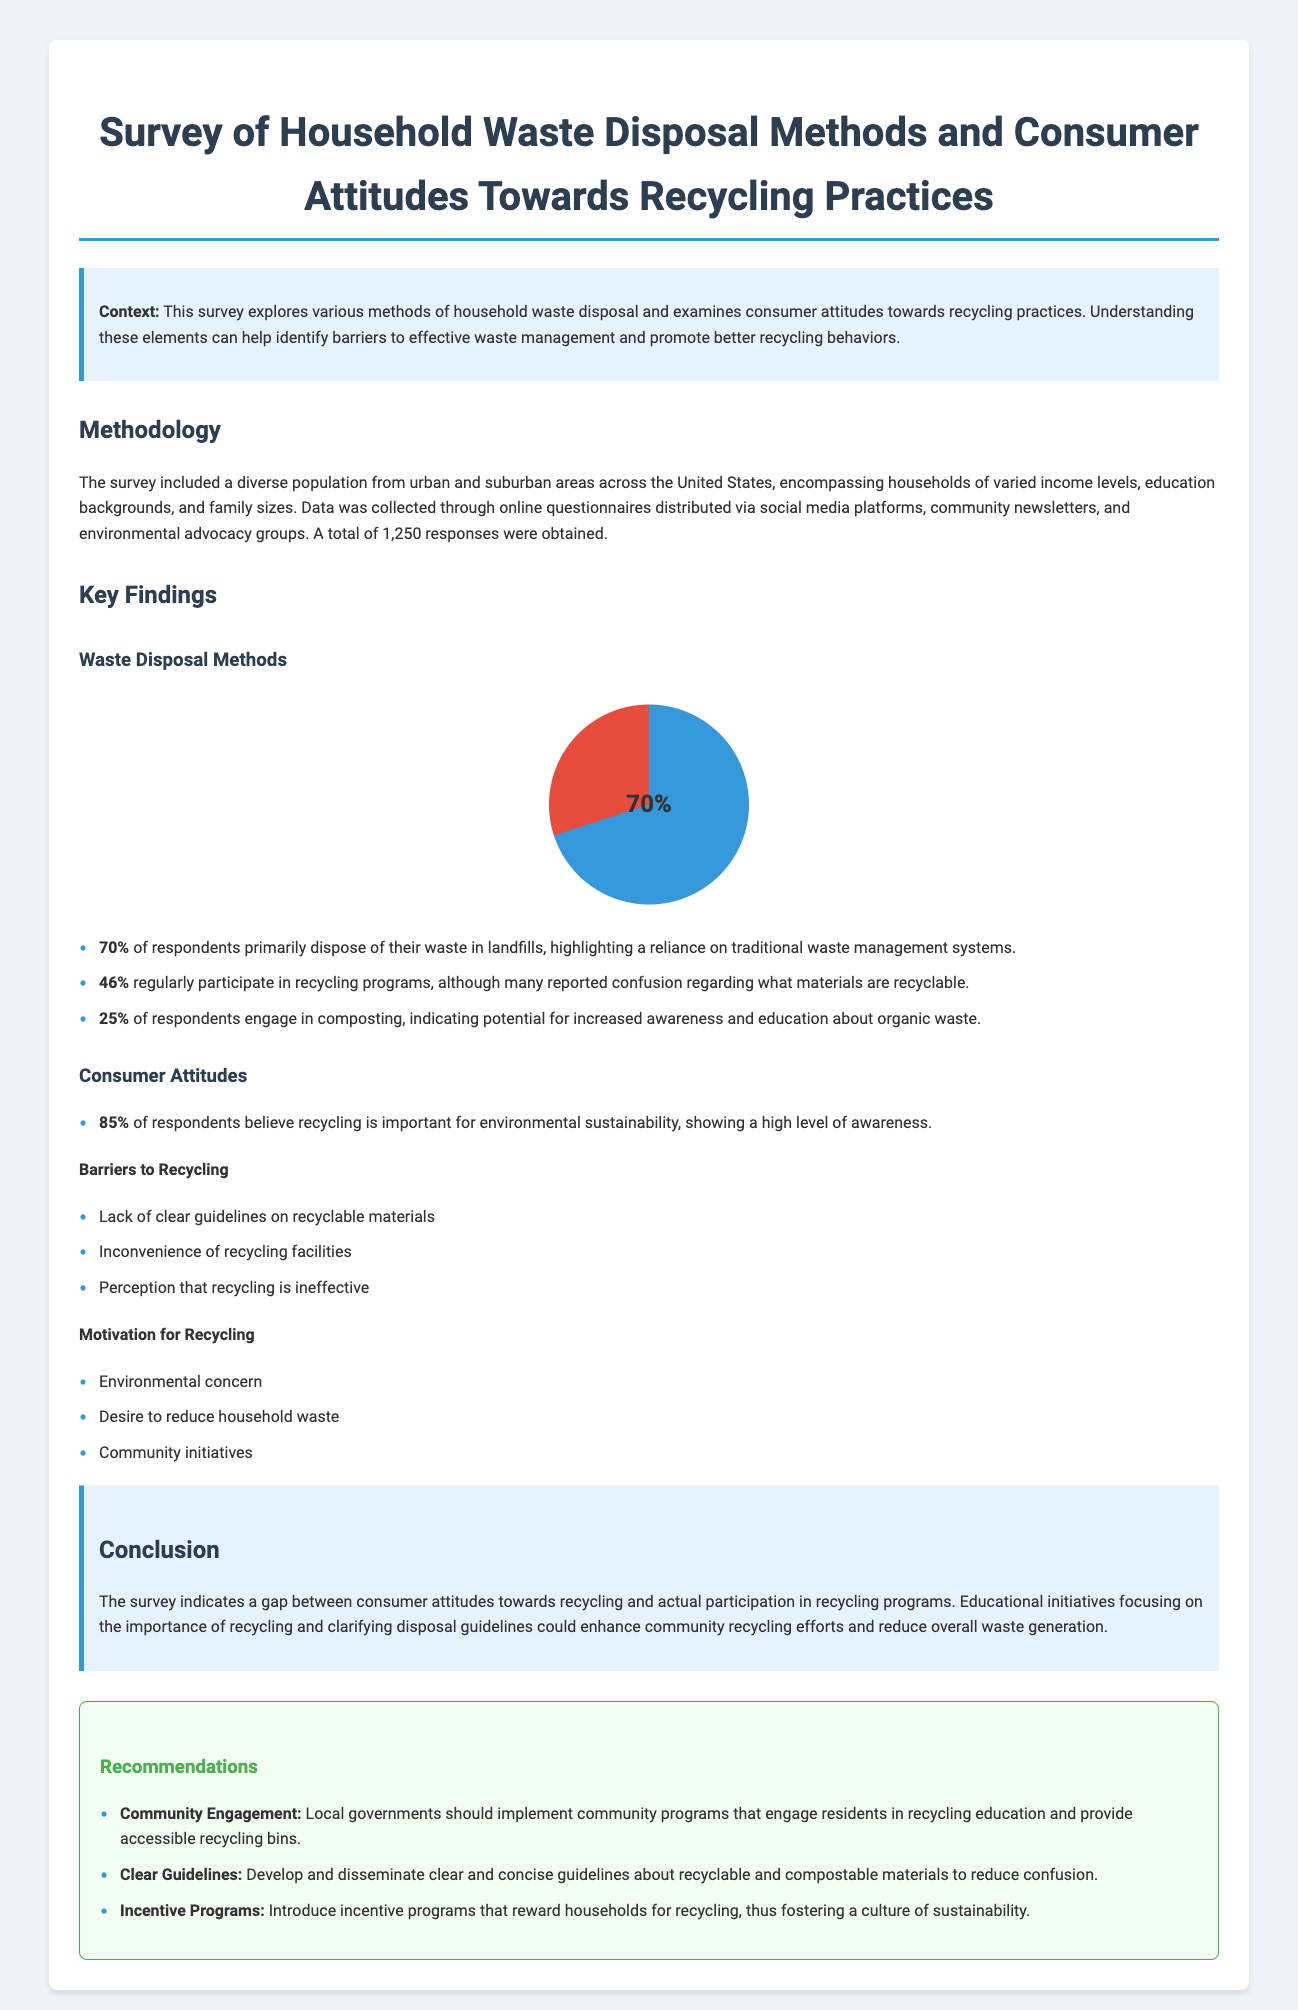what percentage of respondents primarily dispose of their waste in landfills? The document states that 70% of respondents primarily dispose of their waste in landfills.
Answer: 70% how many households participated in the survey? The document mentions that a total of 1,250 responses were obtained from the survey.
Answer: 1,250 what is the main reason cited for recycling by respondents? The document lists "Environmental concern" as one of the main motivations for recycling.
Answer: Environmental concern what percentage of respondents believe recycling is important for environmental sustainability? The document indicates that 85% of respondents believe recycling is important for environmental sustainability.
Answer: 85% what is one barrier to recycling mentioned in the document? The document states that a lack of clear guidelines on recyclable materials is a barrier to recycling.
Answer: Lack of clear guidelines what recommendation is made regarding community engagement? The document recommends implementing community programs that engage residents in recycling education.
Answer: Local governments should implement community programs what percentage of respondents regularly participate in recycling programs? The document reports that 46% of respondents regularly participate in recycling programs.
Answer: 46% what is one motivation for households to recycle according to the survey? The document lists the desire to reduce household waste as a motivation for recycling.
Answer: Desire to reduce household waste what element of consumer behavior does the survey primarily explore? The document explores methods of household waste disposal and consumer attitudes towards recycling practices.
Answer: Household waste disposal and consumer attitudes towards recycling 